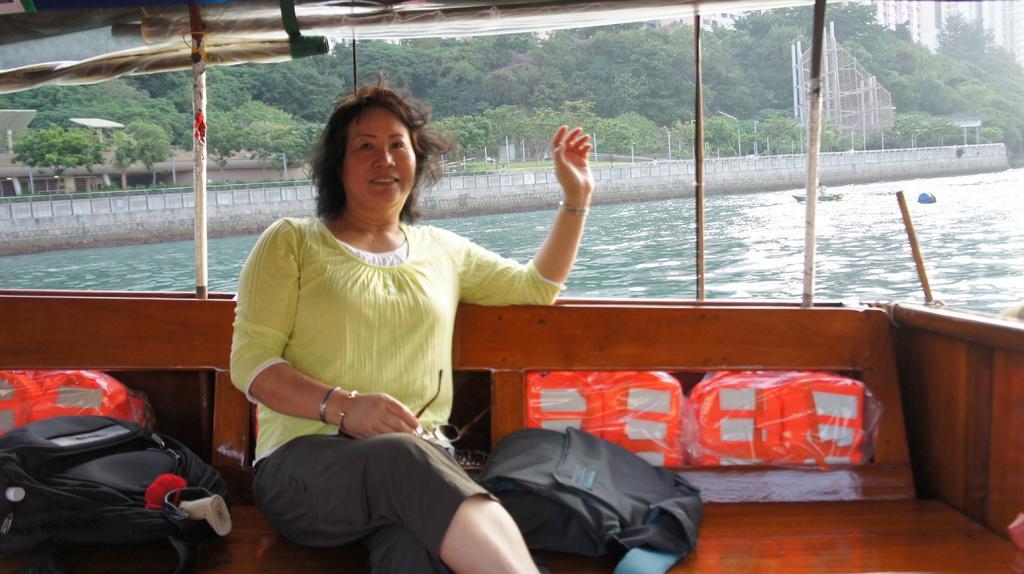Please provide a concise description of this image. The picture is taken in a boat. In the foreground of the picture there is a woman sitting on the bench, behind her there are bags. In the background there are trees, buildings and fencing. In the center of the picture there is water and a wall. 